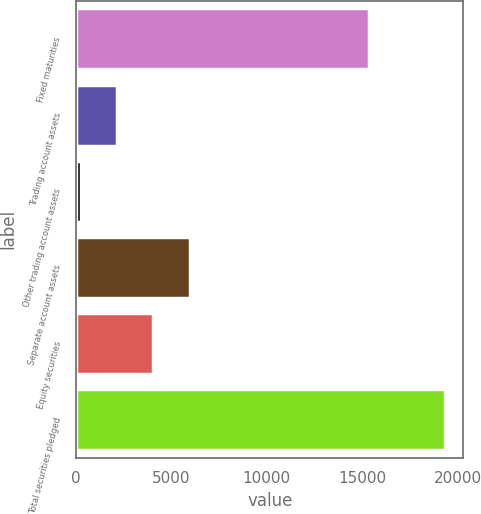<chart> <loc_0><loc_0><loc_500><loc_500><bar_chart><fcel>Fixed maturities<fcel>Trading account assets<fcel>Other trading account assets<fcel>Separate account assets<fcel>Equity securities<fcel>Total securities pledged<nl><fcel>15338<fcel>2141.2<fcel>231<fcel>5961.6<fcel>4051.4<fcel>19333<nl></chart> 